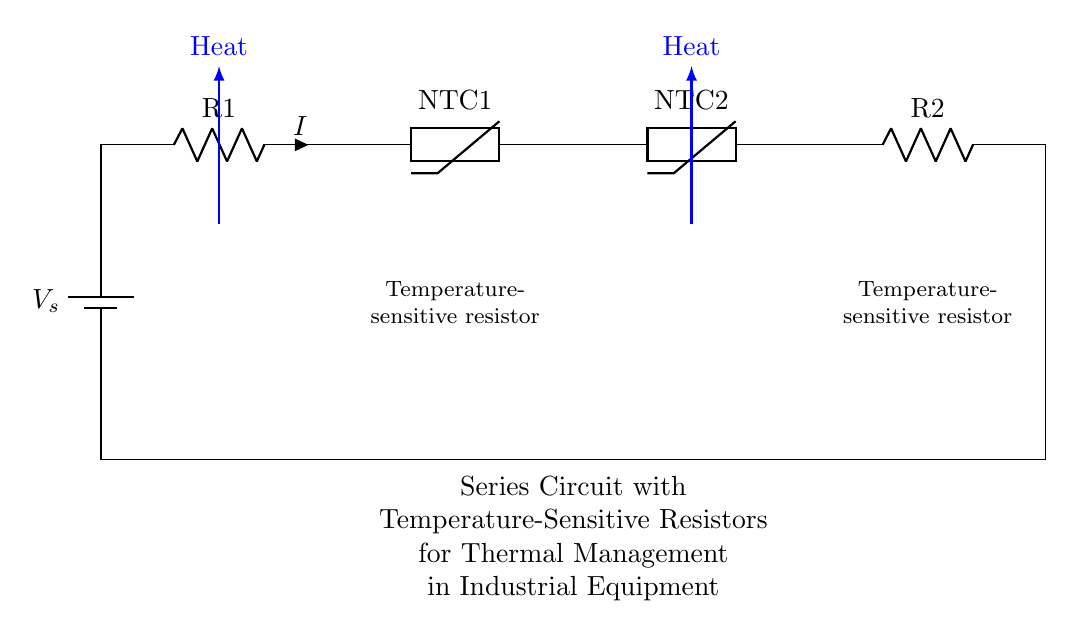What type of resistors are used in this circuit? The circuit uses thermistors, which are temperature-sensitive resistors, indicated by the labels NTC1 and NTC2 in the diagram.
Answer: thermistors How many resistors are in the circuit? There are four resistors in total: two standard resistors (R1 and R2) and two thermistors (NTC1 and NTC2).
Answer: four What is the role of NTC1 in this circuit? NTC1 is a negative temperature coefficient (NTC) thermistor that decreases resistance as the temperature rises, helping to manage and reduce thermal effects in industrial equipment.
Answer: thermal management What happens to the current if the temperature increases? As the temperature increases, the resistance of the thermistors (NTC1 and NTC2) decreases, leading to an increase in current flow through the circuit.
Answer: increases What kind of circuit is this? This is a series circuit, where all components are connected end-to-end in a single path for current flow.
Answer: series circuit What is the significance of using temperature-sensitive resistors? Temperature-sensitive resistors like thermistors improve the safety and efficiency of industrial equipment by adjusting based on temperature changes, preventing overheating.
Answer: thermal regulation What would occur if one thermistor fails? If one thermistor fails, the total resistance of the circuit will change, potentially leading to improper current levels and ineffective thermal management.
Answer: circuit imbalance 